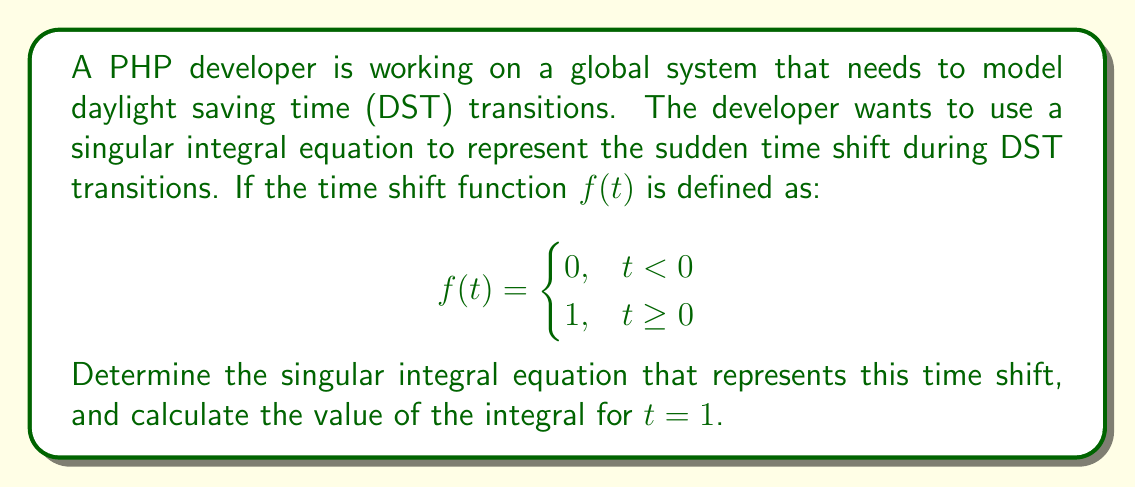Provide a solution to this math problem. To model the sudden time shift during DST transitions, we can use the Cauchy principal value integral, which is a type of singular integral equation. The steps to solve this problem are:

1. The singular integral equation for the time shift function $f(t)$ is given by:

   $$\frac{1}{\pi} \int_{-\infty}^{\infty} \frac{f(\tau)}{t - \tau} d\tau = g(t)$$

   where $g(t)$ is the result of the transformation.

2. Substituting our step function $f(t)$ into the equation:

   $$g(t) = \frac{1}{\pi} \int_{-\infty}^{\infty} \frac{f(\tau)}{t - \tau} d\tau = \frac{1}{\pi} \int_{0}^{\infty} \frac{1}{t - \tau} d\tau$$

3. To evaluate this integral, we need to use the Cauchy principal value:

   $$g(t) = \frac{1}{\pi} \lim_{\epsilon \to 0^+} \left(\int_{0}^{t-\epsilon} \frac{1}{t - \tau} d\tau + \int_{t+\epsilon}^{\infty} \frac{1}{t - \tau} d\tau\right)$$

4. Evaluating the integrals:

   $$g(t) = \frac{1}{\pi} \lim_{\epsilon \to 0^+} \left[-\ln|t-\tau|\bigg|_{0}^{t-\epsilon} - \ln|t-\tau|\bigg|_{t+\epsilon}^{\infty}\right]$$

5. Simplifying:

   $$g(t) = \frac{1}{\pi} \left[\ln|t| - \ln|\epsilon| + \ln|\epsilon|\right] = \frac{1}{\pi} \ln|t|$$

6. For $t = 1$:

   $$g(1) = \frac{1}{\pi} \ln|1| = 0$$

Therefore, the singular integral equation representing the time shift is:

$$g(t) = \frac{1}{\pi} \ln|t|$$

And the value of the integral for $t = 1$ is 0.
Answer: $g(t) = \frac{1}{\pi} \ln|t|$; $g(1) = 0$ 